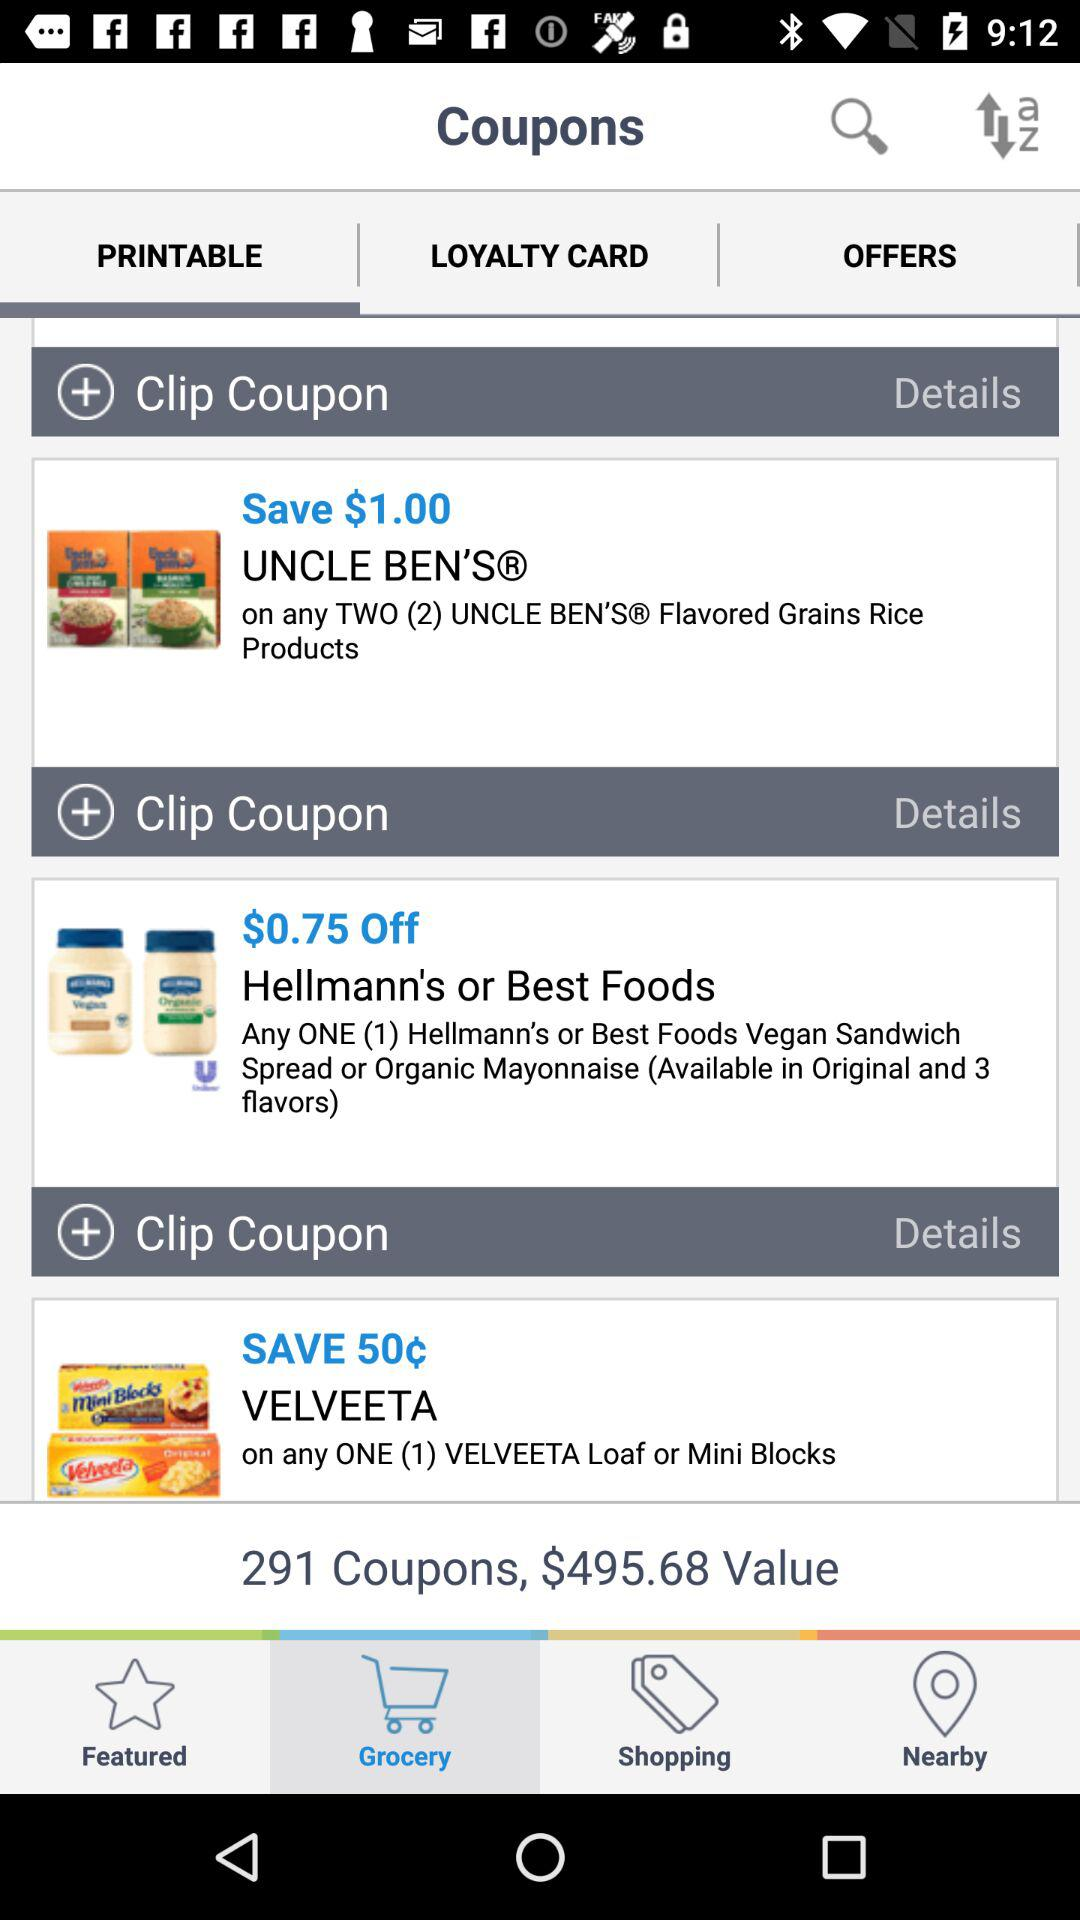What tab is selected? The selected tabs are "Grocery" and "PRINTABLE". 